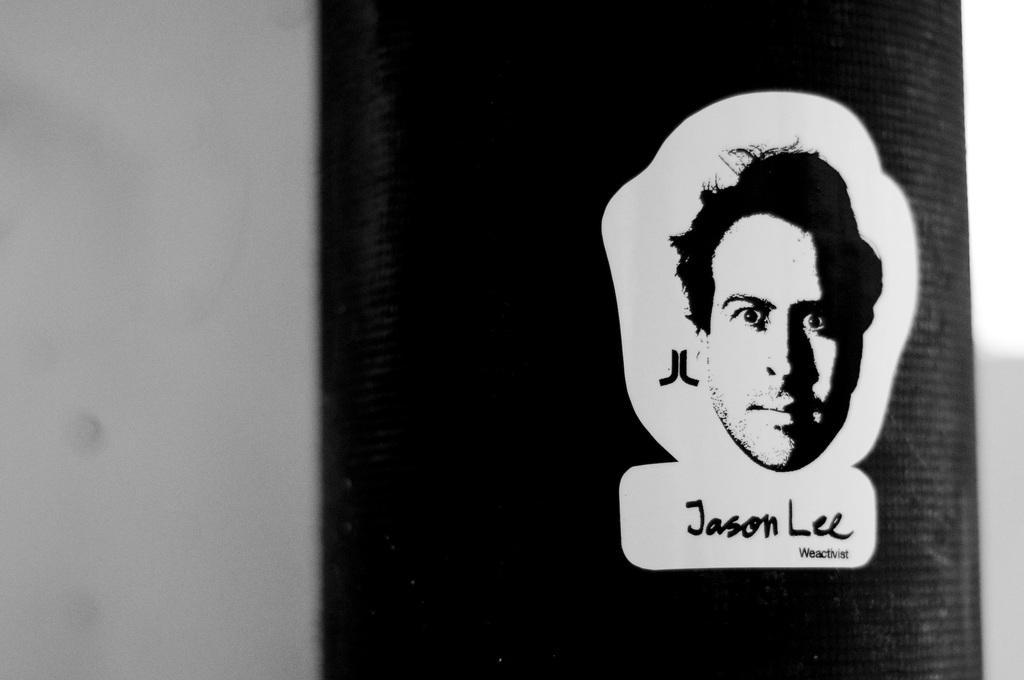How would you summarize this image in a sentence or two? This is a black and white image. In this image we can see a person's head with something written below that. 